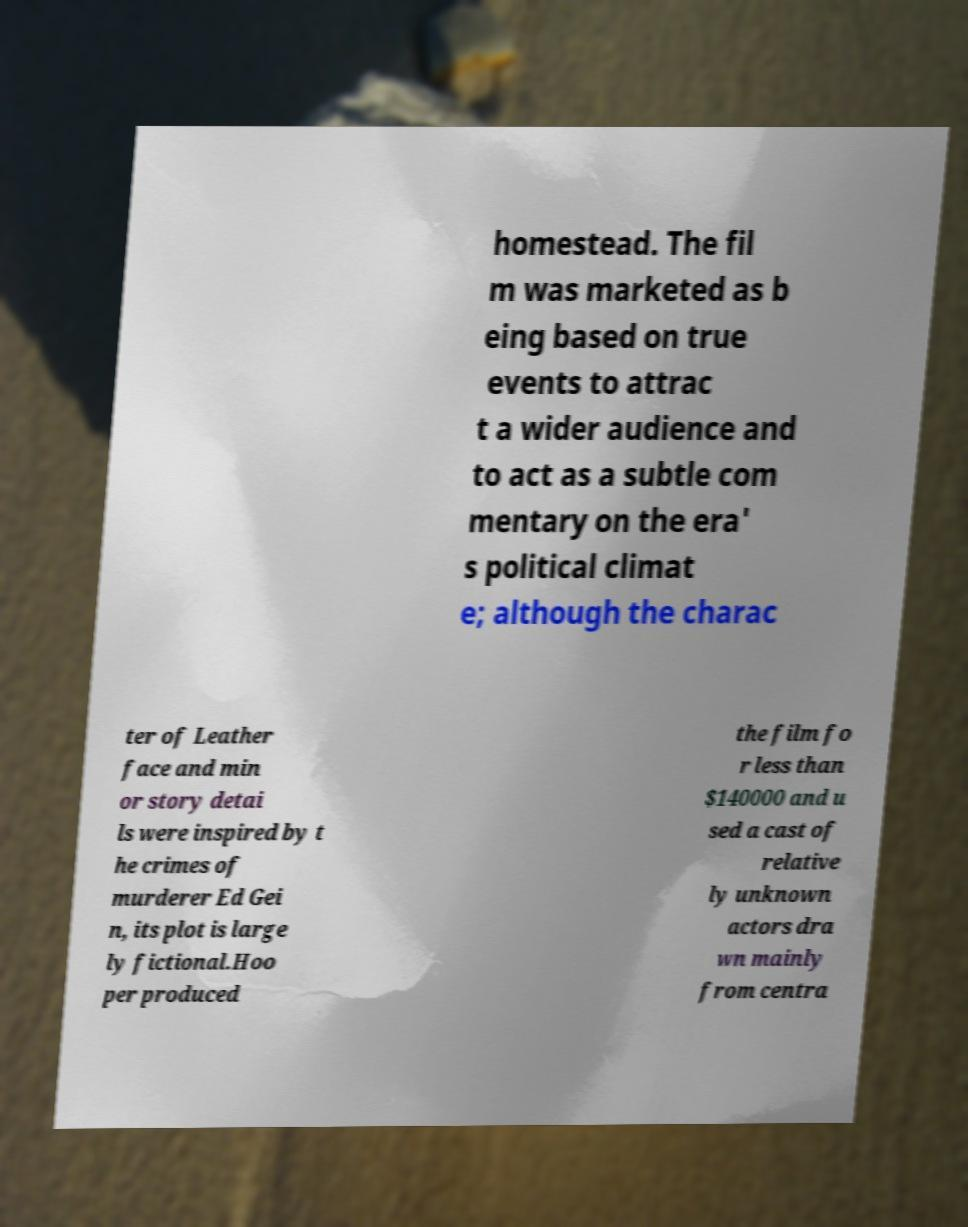Could you assist in decoding the text presented in this image and type it out clearly? homestead. The fil m was marketed as b eing based on true events to attrac t a wider audience and to act as a subtle com mentary on the era' s political climat e; although the charac ter of Leather face and min or story detai ls were inspired by t he crimes of murderer Ed Gei n, its plot is large ly fictional.Hoo per produced the film fo r less than $140000 and u sed a cast of relative ly unknown actors dra wn mainly from centra 